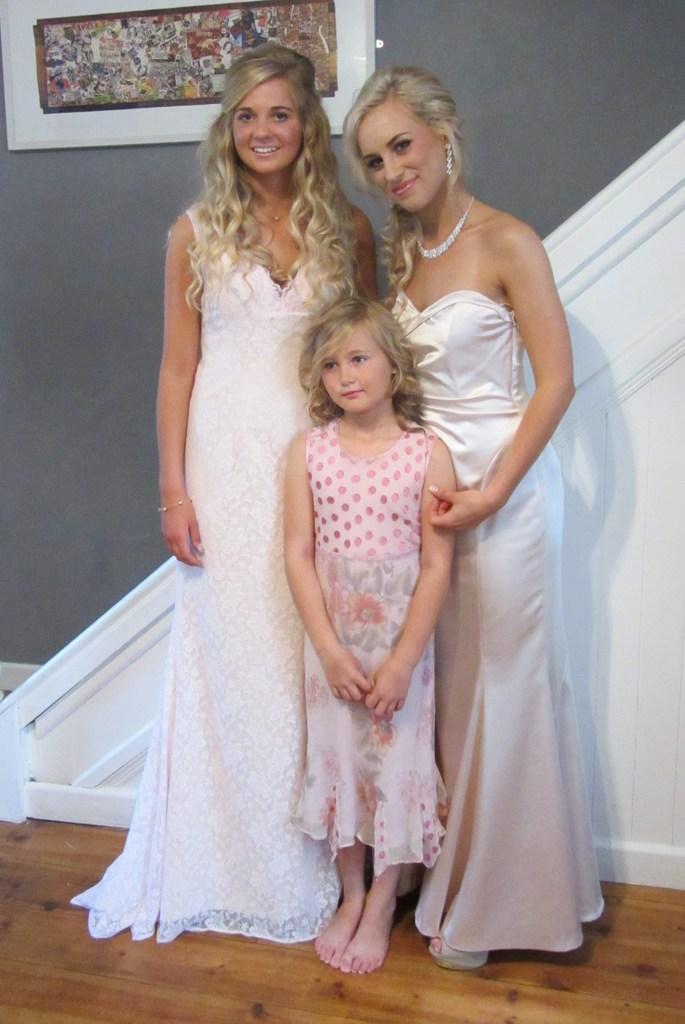In one or two sentences, can you explain what this image depicts? In this picture we can see three people on the floor and in the background we can see a photo frame on the wall. 